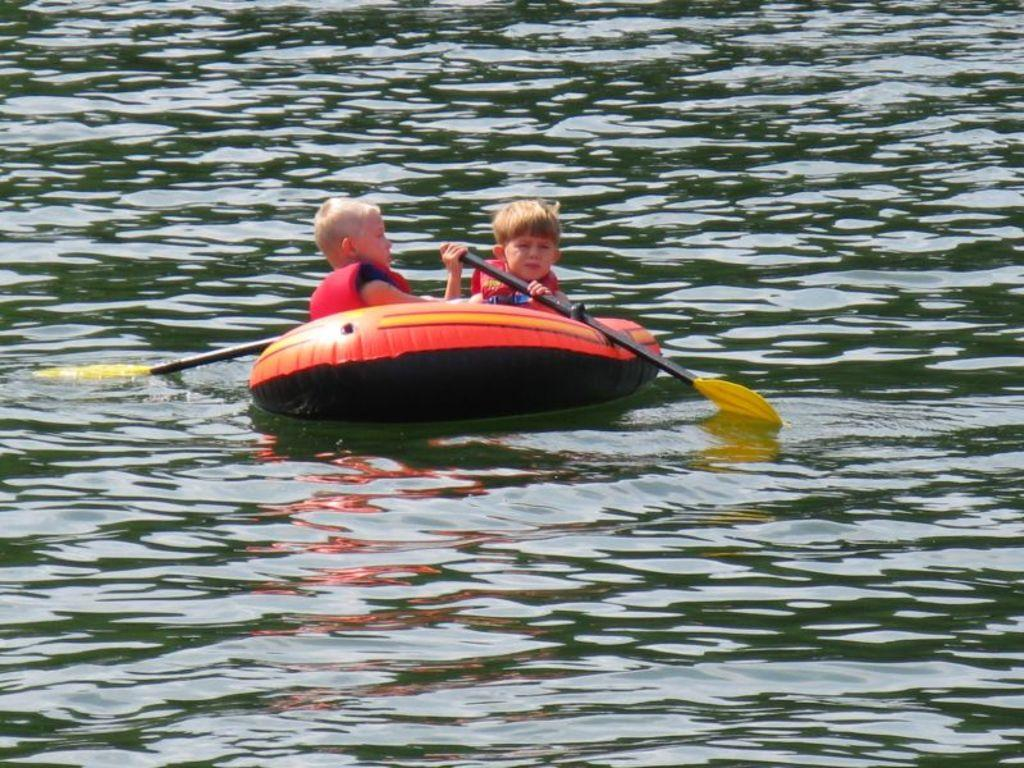How many kids are in the image? There are two kids in the image. What are the kids doing in the image? The kids are sitting on a boat and holding paddles. What is the setting of the image? There is water visible in the image. What type of rock can be seen on the boat in the image? There is no rock present on the boat in the image. What is the kids' favorite color of nail polish? There is no information about the kids' favorite color of nail polish in the image. 